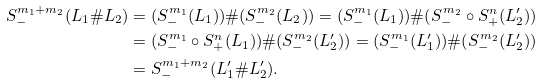Convert formula to latex. <formula><loc_0><loc_0><loc_500><loc_500>S ^ { m _ { 1 } + m _ { 2 } } _ { - } ( L _ { 1 } \# L _ { 2 } ) & = ( S _ { - } ^ { m _ { 1 } } ( L _ { 1 } ) ) \# ( S _ { - } ^ { m _ { 2 } } ( L _ { 2 } ) ) = ( S _ { - } ^ { m _ { 1 } } ( L _ { 1 } ) ) \# ( S ^ { m _ { 2 } } _ { - } \circ S _ { + } ^ { n } ( L _ { 2 } ^ { \prime } ) ) \\ & = ( S _ { - } ^ { m _ { 1 } } \circ S ^ { n } _ { + } ( L _ { 1 } ) ) \# ( S ^ { m _ { 2 } } _ { - } ( L _ { 2 } ^ { \prime } ) ) = ( S _ { - } ^ { m _ { 1 } } ( L _ { 1 } ^ { \prime } ) ) \# ( S ^ { m _ { 2 } } _ { - } ( L _ { 2 } ^ { \prime } ) ) \\ & = S ^ { m _ { 1 } + m _ { 2 } } _ { - } ( L _ { 1 } ^ { \prime } \# L _ { 2 } ^ { \prime } ) .</formula> 